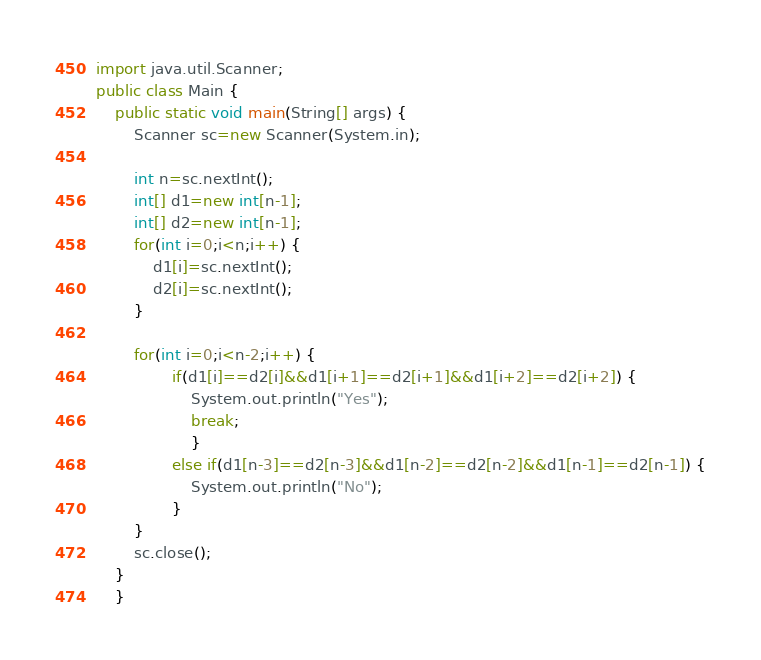Convert code to text. <code><loc_0><loc_0><loc_500><loc_500><_Java_>import java.util.Scanner;
public class Main {
	public static void main(String[] args) {
		Scanner sc=new Scanner(System.in);

		int n=sc.nextInt();
		int[] d1=new int[n-1];
		int[] d2=new int[n-1];
		for(int i=0;i<n;i++) {
			d1[i]=sc.nextInt();
			d2[i]=sc.nextInt();
		}
		
		for(int i=0;i<n-2;i++) {
				if(d1[i]==d2[i]&&d1[i+1]==d2[i+1]&&d1[i+2]==d2[i+2]) {
					System.out.println("Yes");
					break;
					}
				else if(d1[n-3]==d2[n-3]&&d1[n-2]==d2[n-2]&&d1[n-1]==d2[n-1]) {
					System.out.println("No");
				}
		}
		sc.close();
	}
	}</code> 